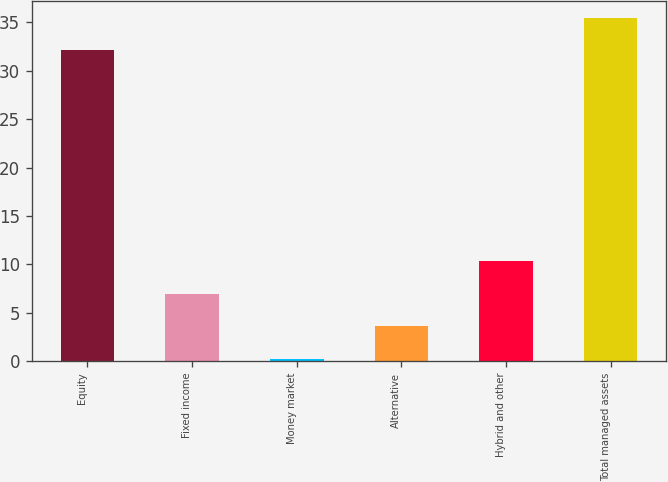<chart> <loc_0><loc_0><loc_500><loc_500><bar_chart><fcel>Equity<fcel>Fixed income<fcel>Money market<fcel>Alternative<fcel>Hybrid and other<fcel>Total managed assets<nl><fcel>32.1<fcel>6.96<fcel>0.2<fcel>3.58<fcel>10.34<fcel>35.48<nl></chart> 